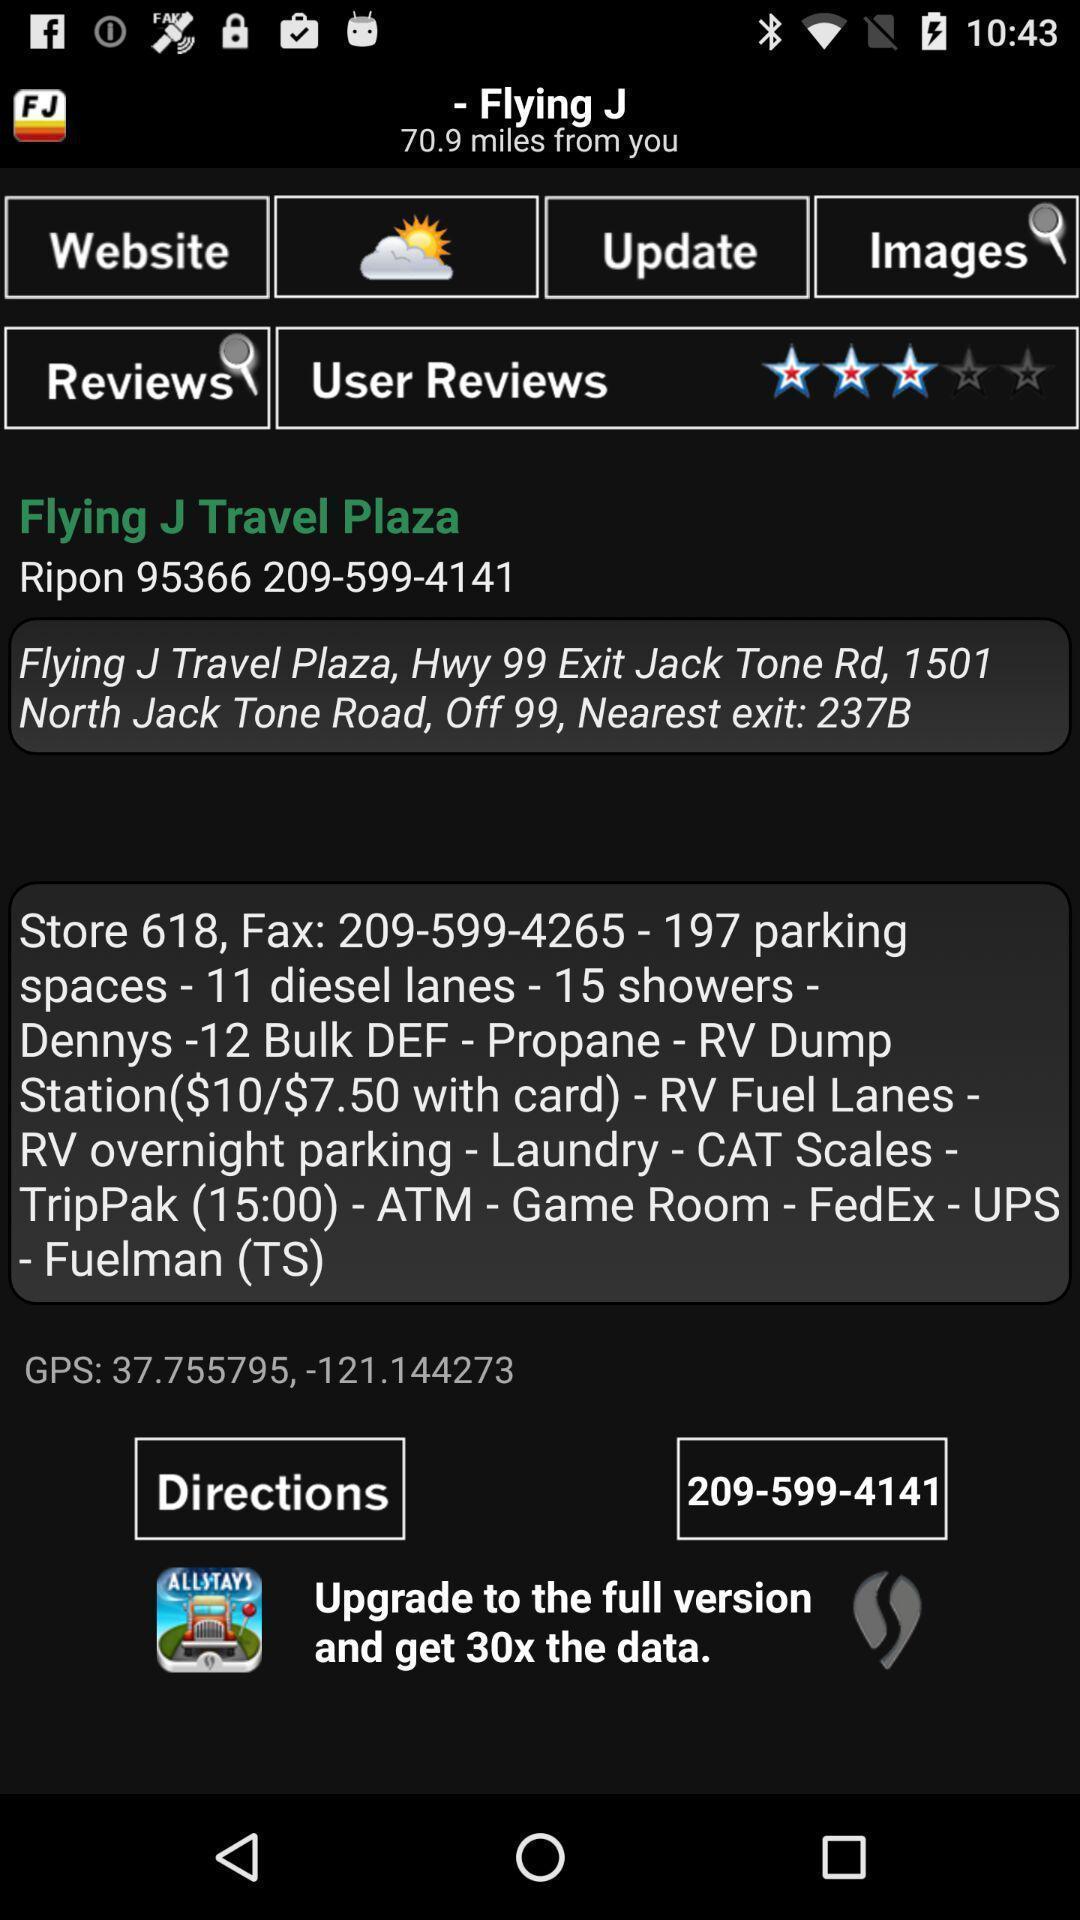What can you discern from this picture? Page displaying reviews images and updates. 